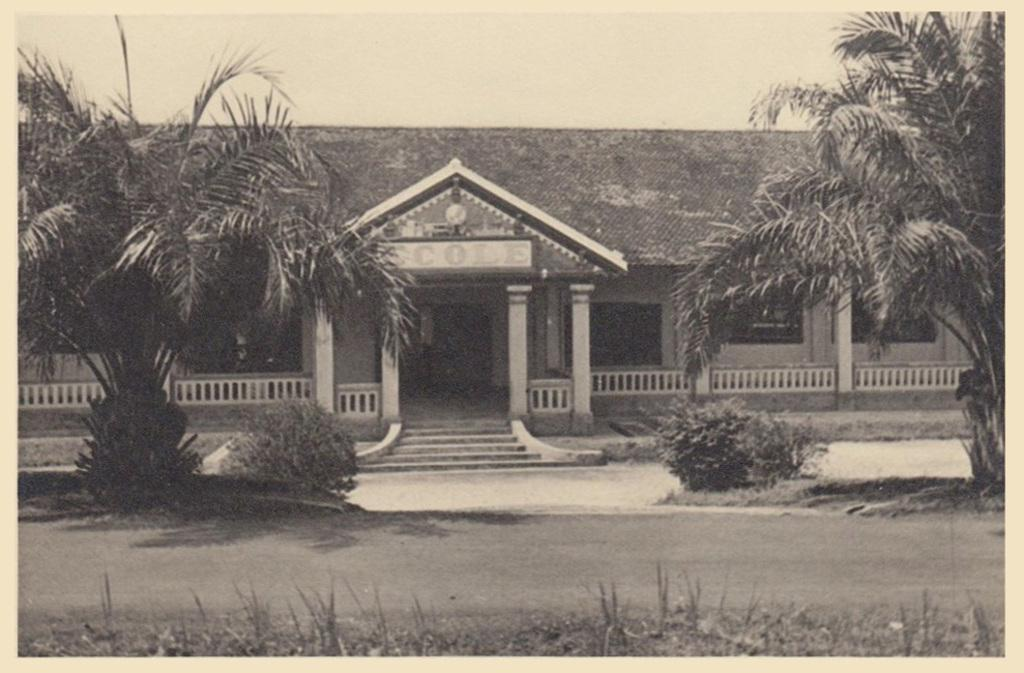What is the main subject of the image? The image contains a photograph. What type of natural environment can be seen in the photograph? There is grass visible in the photograph. Are there any man-made structures in the photograph? Yes, there is a road, a house, and steps in the photograph. What other natural elements are present in the photograph? Shrubs and trees are visible in the photograph. What is visible in the background of the photograph? The sky is visible in the background of the photograph. What type of note is being played on the piano in the photograph? There is no piano present in the photograph; it features a photograph of a natural and man-made environment. What type of pleasure can be seen enjoying the scenery in the photograph? There is no indication of any person or creature enjoying the scenery in the photograph. 